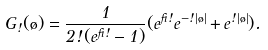Convert formula to latex. <formula><loc_0><loc_0><loc_500><loc_500>G _ { \omega } ( \tau ) = \frac { 1 } { 2 \omega ( e ^ { \beta \omega } - 1 ) } ( e ^ { \beta \omega } e ^ { - \omega | \tau | } + e ^ { \omega | \tau | } ) .</formula> 